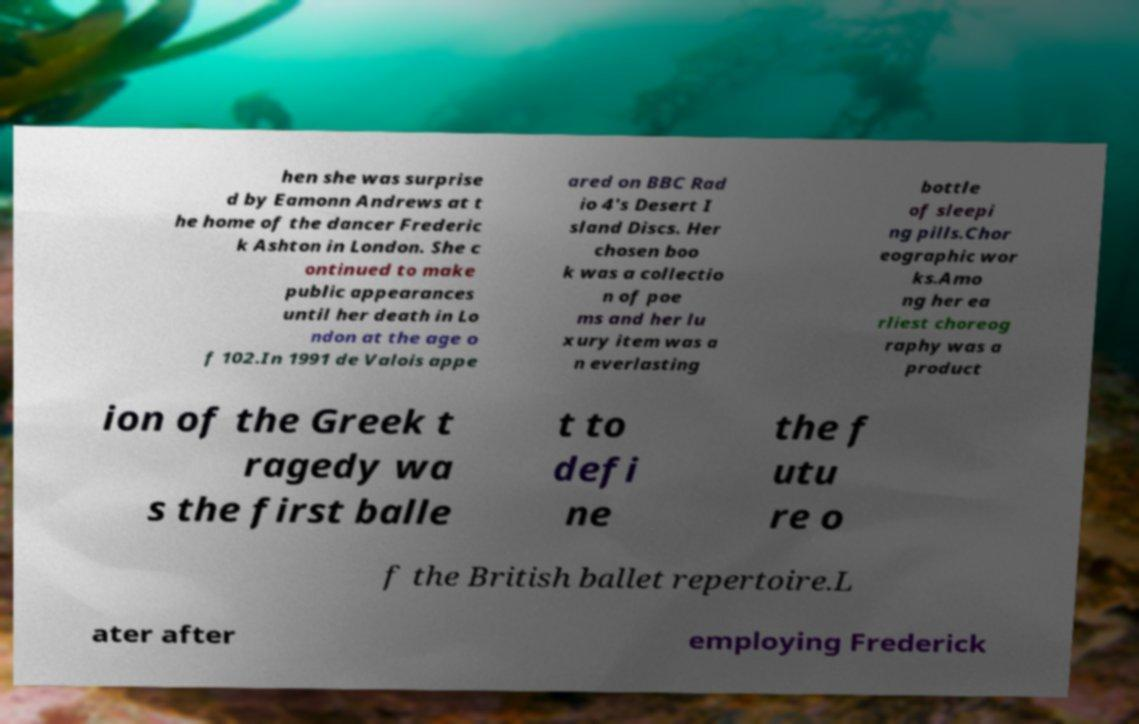Could you extract and type out the text from this image? hen she was surprise d by Eamonn Andrews at t he home of the dancer Frederic k Ashton in London. She c ontinued to make public appearances until her death in Lo ndon at the age o f 102.In 1991 de Valois appe ared on BBC Rad io 4's Desert I sland Discs. Her chosen boo k was a collectio n of poe ms and her lu xury item was a n everlasting bottle of sleepi ng pills.Chor eographic wor ks.Amo ng her ea rliest choreog raphy was a product ion of the Greek t ragedy wa s the first balle t to defi ne the f utu re o f the British ballet repertoire.L ater after employing Frederick 